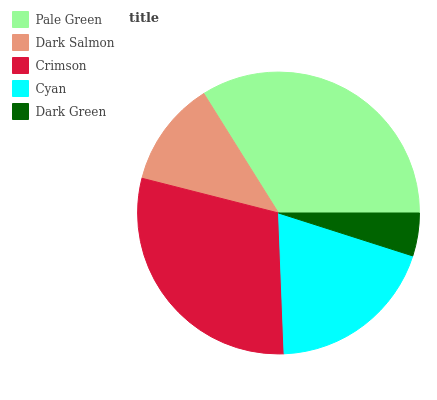Is Dark Green the minimum?
Answer yes or no. Yes. Is Pale Green the maximum?
Answer yes or no. Yes. Is Dark Salmon the minimum?
Answer yes or no. No. Is Dark Salmon the maximum?
Answer yes or no. No. Is Pale Green greater than Dark Salmon?
Answer yes or no. Yes. Is Dark Salmon less than Pale Green?
Answer yes or no. Yes. Is Dark Salmon greater than Pale Green?
Answer yes or no. No. Is Pale Green less than Dark Salmon?
Answer yes or no. No. Is Cyan the high median?
Answer yes or no. Yes. Is Cyan the low median?
Answer yes or no. Yes. Is Dark Green the high median?
Answer yes or no. No. Is Dark Salmon the low median?
Answer yes or no. No. 